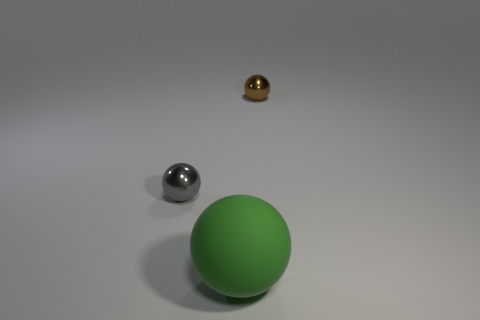What number of other things are there of the same color as the big rubber thing?
Your answer should be compact. 0. What number of other green objects are the same material as the big thing?
Offer a very short reply. 0. What color is the other ball that is made of the same material as the small gray sphere?
Your answer should be very brief. Brown. There is a metallic thing on the left side of the brown metallic sphere; is its size the same as the brown sphere?
Offer a very short reply. Yes. There is a large rubber object that is the same shape as the small brown thing; what is its color?
Give a very brief answer. Green. What shape is the small object that is to the left of the sphere that is behind the shiny object that is left of the small brown object?
Make the answer very short. Sphere. Is the shape of the gray shiny object the same as the green matte object?
Offer a terse response. Yes. There is a big green matte object that is to the right of the metal ball that is to the left of the green matte object; what is its shape?
Make the answer very short. Sphere. Is there a tiny purple sphere?
Provide a succinct answer. No. How many large green matte spheres are left of the big green ball left of the small thing behind the gray ball?
Keep it short and to the point. 0. 